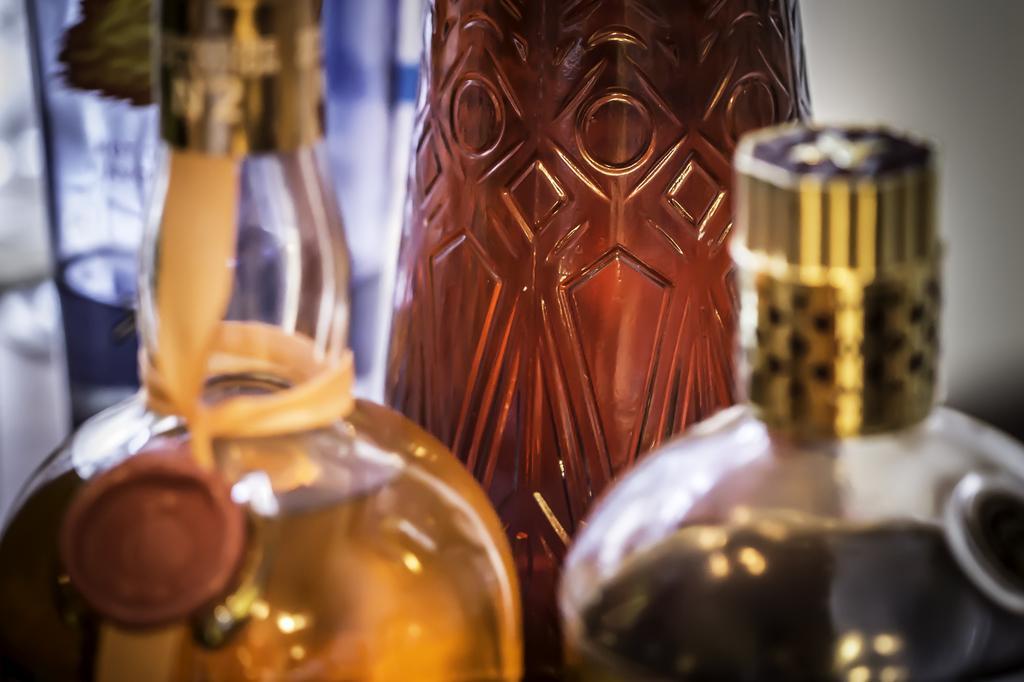In one or two sentences, can you explain what this image depicts? In this image there are two bottles maybe there are wine bottles. In the background there is a wall. 